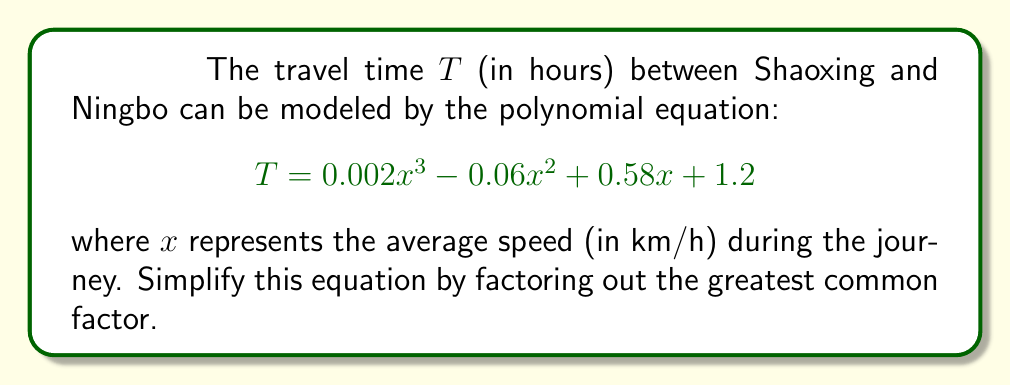Can you solve this math problem? To simplify this polynomial equation by factoring out the greatest common factor (GCF), we need to follow these steps:

1. Identify the terms of the polynomial:
   $0.002x^3$, $-0.06x^2$, $0.58x$, and $1.2$

2. Find the GCF of the coefficients:
   $GCF(0.002, -0.06, 0.58, 1.2) = 0.002$

3. Find the GCF of the variable terms:
   The lowest power of $x$ is $x^0$ (in the constant term), so there's no common $x$ factor.

4. The overall GCF is $0.002$.

5. Factor out the GCF:
   $$\begin{align}
   T &= 0.002x^3 - 0.06x^2 + 0.58x + 1.2 \\
   &= 0.002(x^3 - 30x^2 + 290x + 600)
   \end{align}$$

   To get the coefficients inside the parentheses, we divide each term by 0.002:
   $\frac{0.002}{0.002} = 1$
   $\frac{-0.06}{0.002} = -30$
   $\frac{0.58}{0.002} = 290$
   $\frac{1.2}{0.002} = 600$

Thus, the simplified equation is $T = 0.002(x^3 - 30x^2 + 290x + 600)$.
Answer: $T = 0.002(x^3 - 30x^2 + 290x + 600)$ 